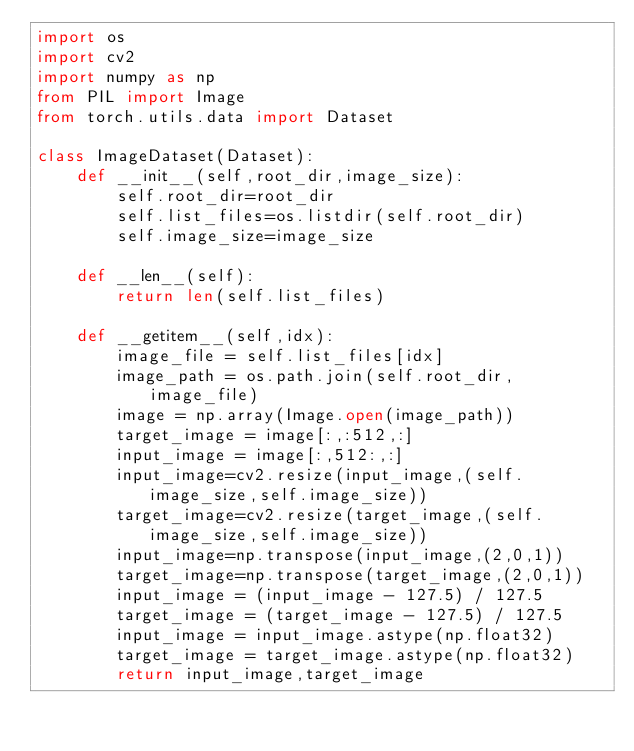<code> <loc_0><loc_0><loc_500><loc_500><_Python_>import os
import cv2
import numpy as np
from PIL import Image
from torch.utils.data import Dataset

class ImageDataset(Dataset):
    def __init__(self,root_dir,image_size):
        self.root_dir=root_dir
        self.list_files=os.listdir(self.root_dir)
        self.image_size=image_size
        
    def __len__(self):
        return len(self.list_files)
        
    def __getitem__(self,idx):
        image_file = self.list_files[idx]
        image_path = os.path.join(self.root_dir,image_file)
        image = np.array(Image.open(image_path))
        target_image = image[:,:512,:]
        input_image = image[:,512:,:]
        input_image=cv2.resize(input_image,(self.image_size,self.image_size))
        target_image=cv2.resize(target_image,(self.image_size,self.image_size))
        input_image=np.transpose(input_image,(2,0,1))
        target_image=np.transpose(target_image,(2,0,1))
        input_image = (input_image - 127.5) / 127.5
        target_image = (target_image - 127.5) / 127.5
        input_image = input_image.astype(np.float32)
        target_image = target_image.astype(np.float32)
        return input_image,target_image
        </code> 